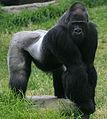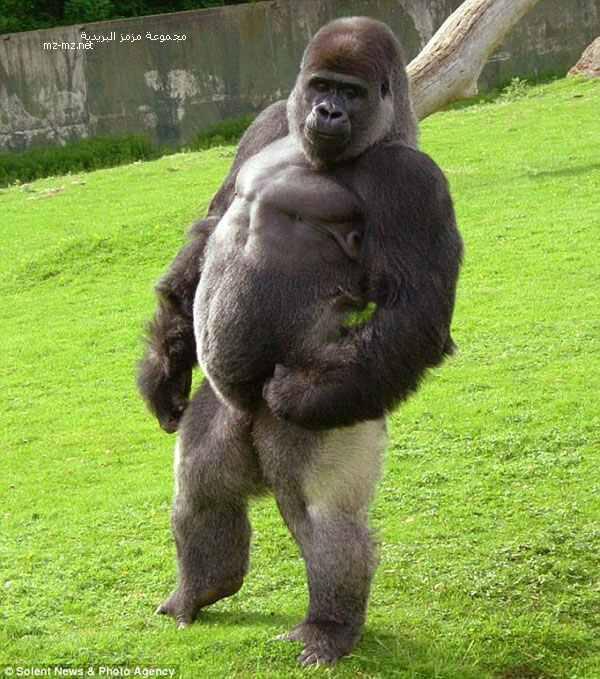The first image is the image on the left, the second image is the image on the right. Assess this claim about the two images: "The right image contains one gorilla standing upright on two legs.". Correct or not? Answer yes or no. Yes. The first image is the image on the left, the second image is the image on the right. Examine the images to the left and right. Is the description "An ape is standing on two legs." accurate? Answer yes or no. Yes. 